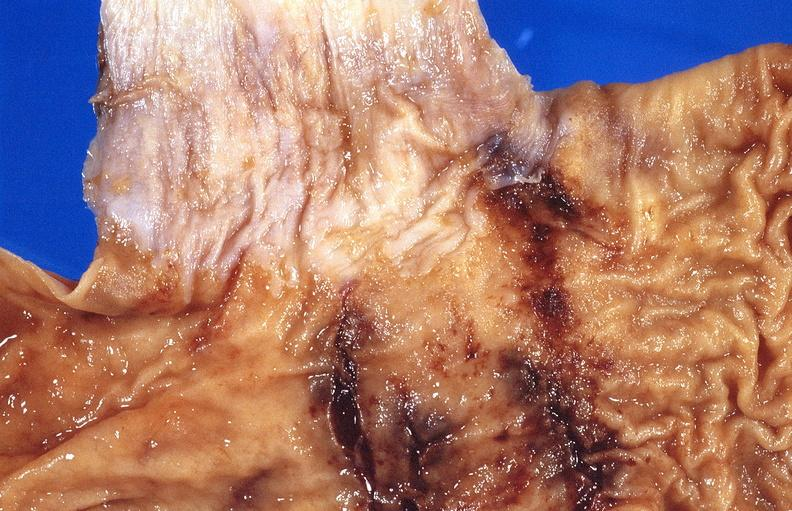s gastrointestinal present?
Answer the question using a single word or phrase. Yes 